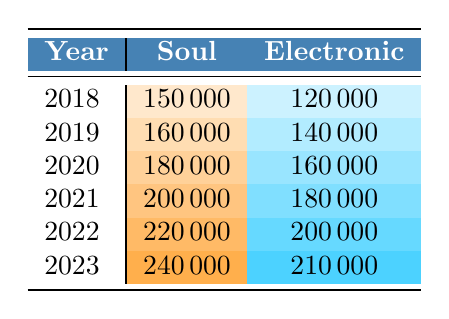What was the total sales of Soul records in 2021? From the table, we can see that the sales of Soul records for the year 2021 is 200,000.
Answer: 200000 In which year did Electronic record sales first exceed 180,000? Looking through the years, Electronic record sales were 120,000 in 2018, 140,000 in 2019, 160,000 in 2020, and reached 180,000 in 2021. Therefore, 2021 is the first year where it exceeds 180,000.
Answer: 2021 What is the difference in sales between Soul and Electronic genres in 2022? The sales for Soul records in 2022 is 220,000, and for Electronic records is 200,000. The difference is calculated by subtracting the Electronic sales from the Soul sales: 220,000 - 200,000 = 20,000.
Answer: 20000 Which genre had higher sales in 2023? The table shows Soul records in 2023 had sales of 240,000 while Electronic records had sales of 210,000. Therefore, Soul had higher sales in 2023.
Answer: Yes What is the average sales for Electronic records from 2018 to 2023? To find the average sales for Electronic records, we sum the sales for each year: 120,000 (2018) + 140,000 (2019) + 160,000 (2020) + 180,000 (2021) + 200,000 (2022) + 210,000 (2023) = 1,110,000. Then we divide by the number of years (6): 1,110,000 / 6 = 185,000.
Answer: 185000 Did Soul record sales increase every year from 2018 to 2023? By observing the data, we see that the Soul sales increased from 150,000 in 2018 to 240,000 in 2023, with each subsequent year showing an increase. Thus, the answer is yes.
Answer: Yes What was the total vinyl sales across all genres in 2020? To get the total vinyl sales in 2020, we add the sales of both genres: 180,000 (Soul) + 160,000 (Electronic) = 340,000.
Answer: 340000 Which year had the lowest sales for Electronic records? Checking the values, in 2018, Electronic records had sales of 120,000, which is lower than the other years listed.
Answer: 2018 